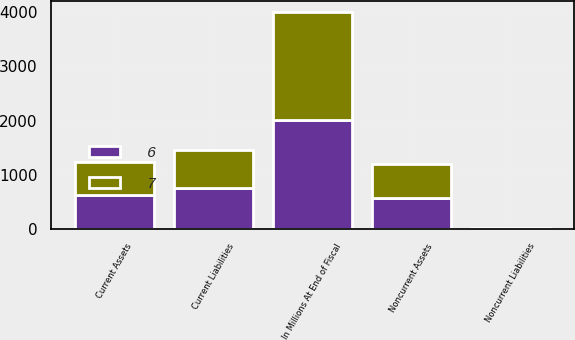Convert chart to OTSL. <chart><loc_0><loc_0><loc_500><loc_500><stacked_bar_chart><ecel><fcel>In Millions At End of Fiscal<fcel>Current Assets<fcel>Noncurrent Assets<fcel>Current Liabilities<fcel>Noncurrent Liabilities<nl><fcel>6<fcel>2006<fcel>634<fcel>578<fcel>756<fcel>6<nl><fcel>7<fcel>2005<fcel>604<fcel>612<fcel>695<fcel>7<nl></chart> 